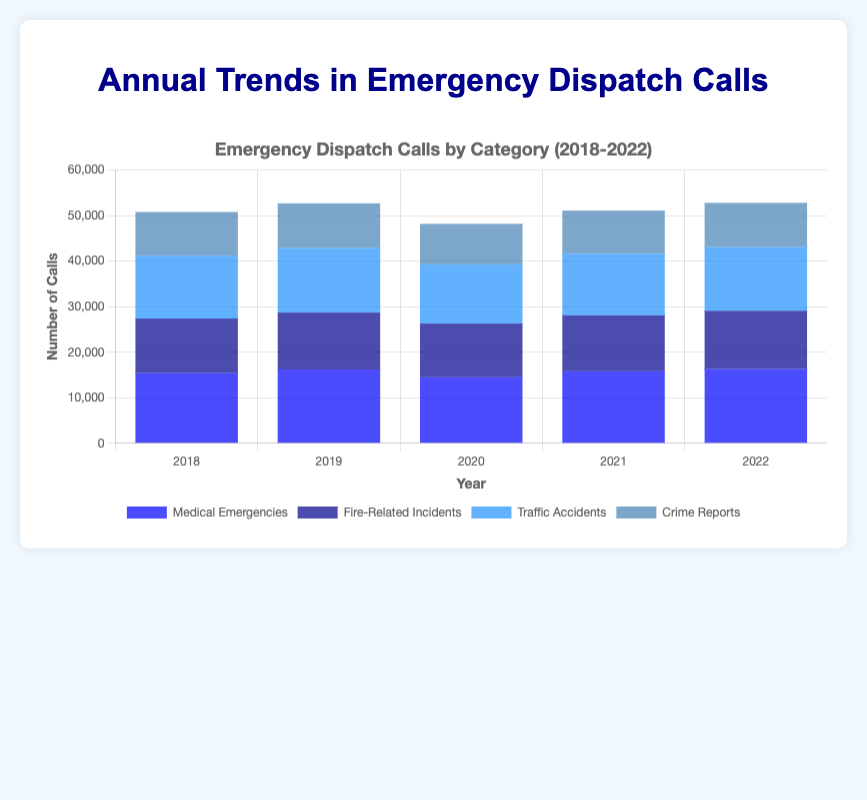What was the trend in medical emergencies from 2018 to 2022? The data shows the number of medical emergencies for each year: 2018 (15400), 2019 (16200), 2020 (14500), 2021 (15800), 2022 (16300). Overall, there is an increase in medical emergencies, with a dip in 2020.
Answer: Increasing, with a dip in 2020 Which year had the highest number of fire-related incidents? By examining the number of fire-related incidents each year: 2018 (12000), 2019 (12500), 2020 (11800), 2021 (12300), 2022 (12800), it is clear that 2022 had the highest number of fire-related incidents.
Answer: 2022 Compare the number of traffic accidents in 2018 and 2020. In 2018, there were 13800 traffic accidents, and in 2020, there were 13000. To compare, 2018 had more traffic accidents.
Answer: 2018 had more What is the average number of crime reports per year from 2018 to 2022? The total number of crime reports over the five years is 9600 + 9800 + 8900 + 9500 + 9700 = 47500. Dividing this by 5, the average number of crime reports per year is 47500 / 5 = 9500.
Answer: 9500 Which category had the most significant decrease in calls between any two consecutive years? By examining the yearly data for each category:
- Medical emergencies: 16200 in 2019 to 14500 in 2020 (1700 decrease)
- Fire-related incidents: 12500 in 2019 to 11800 in 2020 (700 decrease)
- Traffic accidents: 14200 in 2019 to 13000 in 2020 (1200 decrease)
- Crime reports: 9800 in 2019 to 8900 in 2020 (900 decrease)
The most significant decrease was in medical emergencies between 2019 and 2020.
Answer: Medical emergencies (2019-2020) Which year had the lowest total number of emergency dispatch calls across all categories? Summing the numbers for each year:
- 2018: 15400 + 12000 + 13800 + 9600 = 50800
- 2019: 16200 + 12500 + 14200 + 9800 = 52700
- 2020: 14500 + 11800 + 13000 + 8900 = 48200
- 2021: 15800 + 12300 + 13500 + 9500 = 51100
- 2022: 16300 + 12800 + 14000 + 9700 = 52800
2020 had the lowest total number of emergency dispatch calls.
Answer: 2020 What are the proportions of each type of emergency dispatch call in 2022? Calculating the proportions in 2022:
- Total calls in 2022: 16300 + 12800 + 14000 + 9700 = 52800
- Medical emergencies: 16300 / 52800 ≈ 0.308 (30.8%)
- Fire-related incidents: 12800 / 52800 ≈ 0.242 (24.2%)
- Traffic accidents: 14000 / 52800 ≈ 0.265 (26.5%)
- Crime reports: 9700 / 52800 ≈ 0.184 (18.4%)
The proportions are approximately 30.8% medical emergencies, 24.2% fire-related incidents, 26.5% traffic accidents, and 18.4% crime reports.
Answer: Medical: 30.8%, Fire: 24.2%, Traffic: 26.5%, Crime: 18.4% Which category's bar is the tallest in the year 2020? By visually comparing the bars for 2020, the tallest one corresponds to medical emergencies, which have a count of 14500.
Answer: Medical emergencies What is the difference in the number of medical emergencies between 2018 and 2022? The number of medical emergencies in 2018 was 15400, and in 2022, it was 16300. The difference is 16300 - 15400 = 900.
Answer: 900 How did traffic accidents vary over the years and were there any years with decreasing trends? The number of traffic accidents each year is: 2018 (13800), 2019 (14200), 2020 (13000), 2021 (13500), 2022 (14000). There was a decrease from 2019 to 2020.
Answer: Decreased from 2019 to 2020 